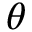Convert formula to latex. <formula><loc_0><loc_0><loc_500><loc_500>\theta</formula> 